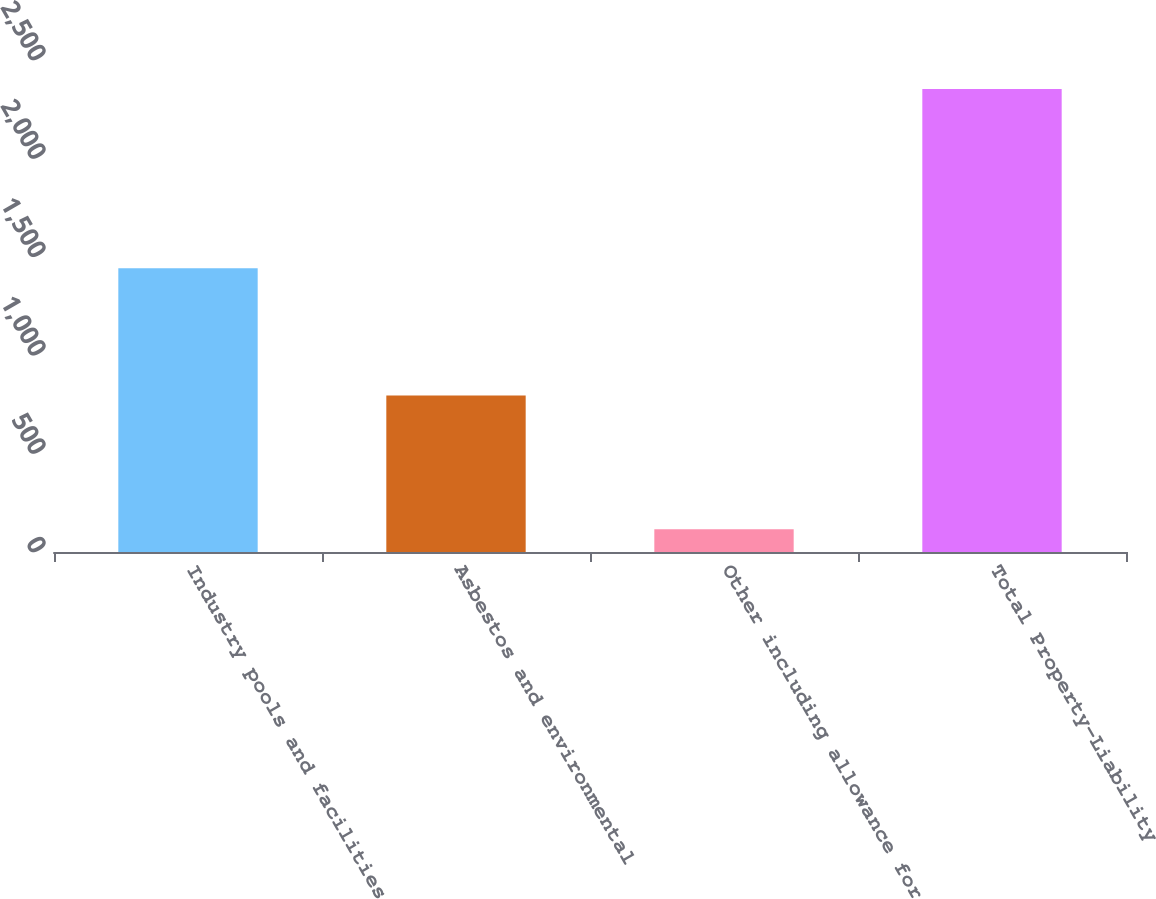Convert chart. <chart><loc_0><loc_0><loc_500><loc_500><bar_chart><fcel>Industry pools and facilities<fcel>Asbestos and environmental<fcel>Other including allowance for<fcel>Total Property-Liability<nl><fcel>1442<fcel>795<fcel>116<fcel>2353<nl></chart> 